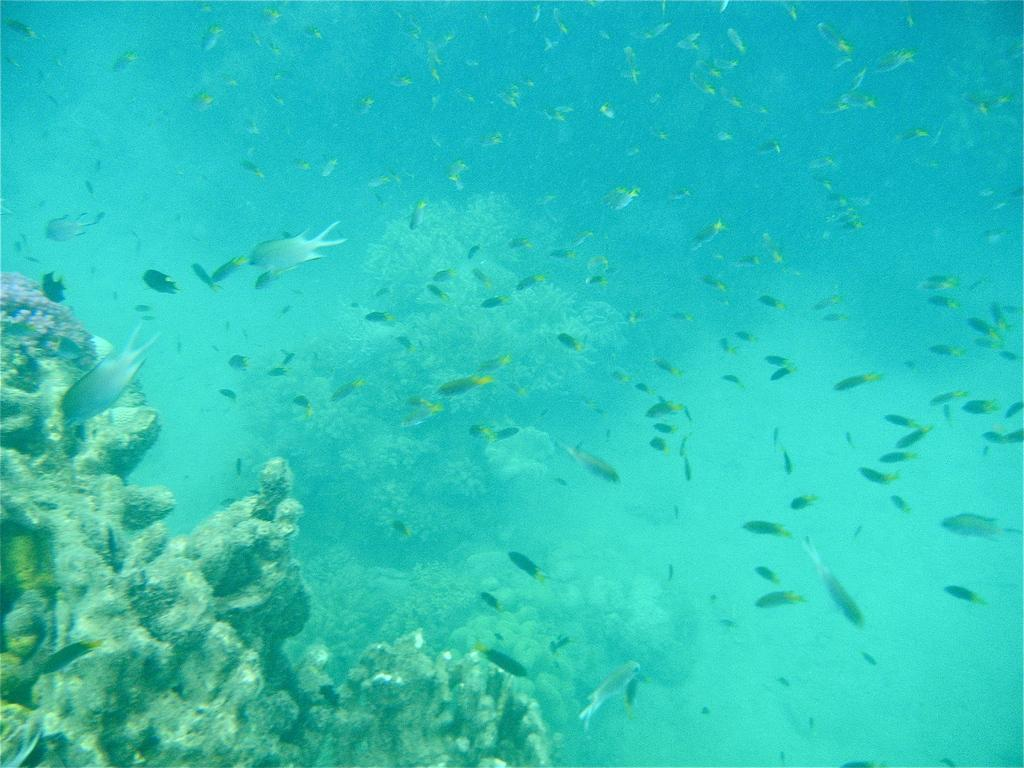What type of environment is depicted in the image? The image shows a deep sea environment. What types of vegetation can be seen in the deep sea? There are water plants in the deep sea. What other objects are present in the deep sea? There are stones in the deep sea. What kind of marine life can be observed in the image? There are different kinds of fishes in the deep sea. What is the view like from the top of the light in the image? There is no light present in the image, so it is not possible to describe a view from the top of it. 